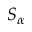Convert formula to latex. <formula><loc_0><loc_0><loc_500><loc_500>S _ { \alpha }</formula> 